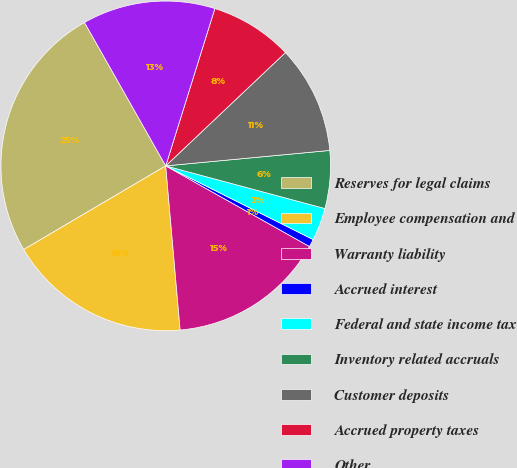Convert chart. <chart><loc_0><loc_0><loc_500><loc_500><pie_chart><fcel>Reserves for legal claims<fcel>Employee compensation and<fcel>Warranty liability<fcel>Accrued interest<fcel>Federal and state income tax<fcel>Inventory related accruals<fcel>Customer deposits<fcel>Accrued property taxes<fcel>Other<nl><fcel>25.27%<fcel>17.92%<fcel>15.47%<fcel>0.76%<fcel>3.21%<fcel>5.66%<fcel>10.57%<fcel>8.12%<fcel>13.02%<nl></chart> 